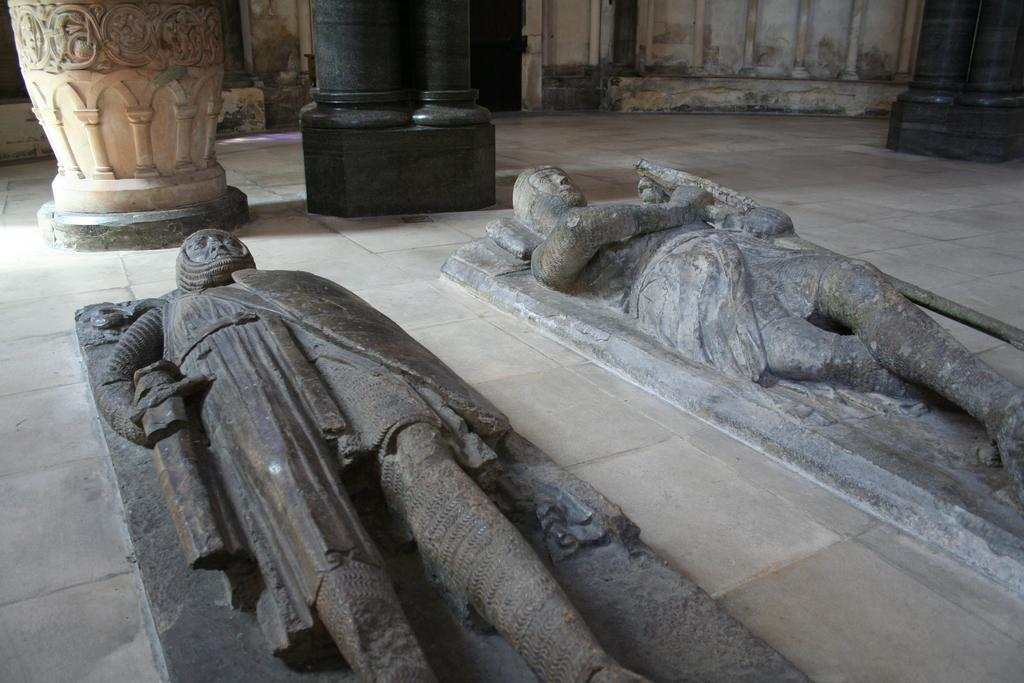What type of art is present in the image? There are sculptures in the image. What architectural elements can be seen in the image? There are pillars in the image. How does the growth of the sculptures affect the stability of the pillars in the image? There is no indication of growth in the image, and the sculptures and pillars are separate entities. The growth of the sculptures would not affect the stability of the pillars. 